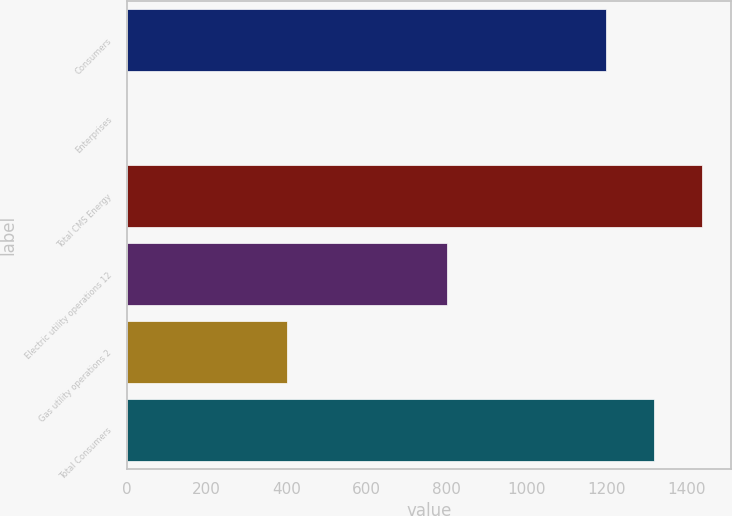<chart> <loc_0><loc_0><loc_500><loc_500><bar_chart><fcel>Consumers<fcel>Enterprises<fcel>Total CMS Energy<fcel>Electric utility operations 12<fcel>Gas utility operations 2<fcel>Total Consumers<nl><fcel>1200<fcel>1<fcel>1440<fcel>800<fcel>400<fcel>1320<nl></chart> 